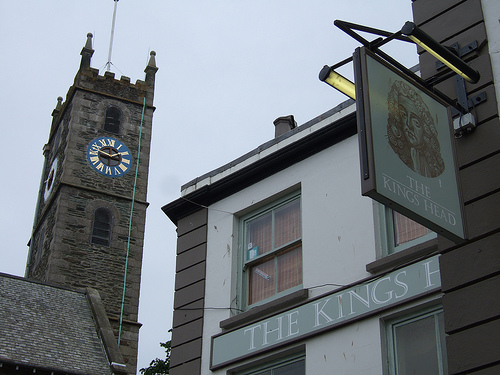What kind of architecture is featured in the buildings? The buildings in the image exhibit a mix of traditional and historic architectural styles. The clock tower has Gothic elements, characterized by its pointed arches and old stone construction. The adjacent building has some modern touches but retains a quaint, charming aesthetic with traditional window designs. 